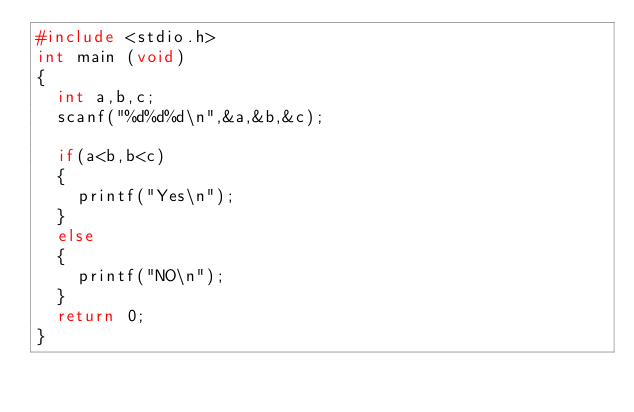Convert code to text. <code><loc_0><loc_0><loc_500><loc_500><_C_>#include <stdio.h>
int main (void)
{
	int a,b,c;
	scanf("%d%d%d\n",&a,&b,&c);
	
	if(a<b,b<c)
	{
		printf("Yes\n");
	}
	else
	{
		printf("NO\n");
	}
	return 0;
}</code> 